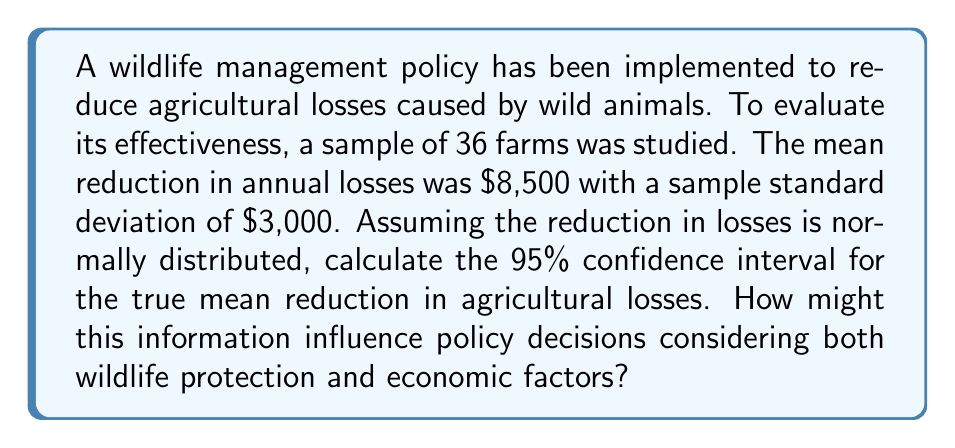Can you solve this math problem? Let's approach this step-by-step:

1) We're given:
   - Sample size: $n = 36$
   - Sample mean: $\bar{x} = \$8,500$
   - Sample standard deviation: $s = \$3,000$
   - Confidence level: 95%

2) For a 95% confidence interval, we use a z-score of 1.96 (assuming a large sample size).

3) The formula for the confidence interval is:

   $$\bar{x} \pm z \cdot \frac{s}{\sqrt{n}}$$

4) Let's calculate the standard error:
   
   $$SE = \frac{s}{\sqrt{n}} = \frac{3000}{\sqrt{36}} = \frac{3000}{6} = 500$$

5) Now, let's calculate the margin of error:

   $$ME = z \cdot SE = 1.96 \cdot 500 = 980$$

6) Finally, we can calculate the confidence interval:

   Lower bound: $8500 - 980 = 7520$
   Upper bound: $8500 + 980 = 9480$

7) Therefore, we are 95% confident that the true mean reduction in agricultural losses is between $7,520 and $9,480.

This information can influence policy decisions by providing a range of expected economic benefits. Policymakers can weigh these benefits against the costs of wildlife management and protection measures. If the lower bound still represents a significant economic gain, it may justify continued or expanded wildlife management efforts.
Answer: 95% CI: ($7,520, $9,480) 